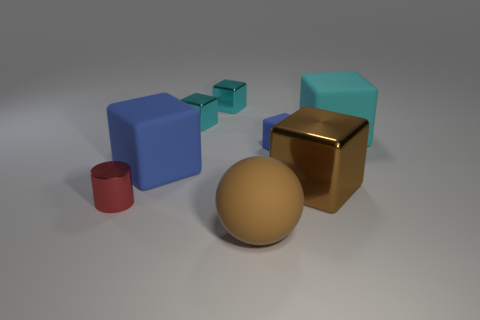Is there another object that has the same material as the small blue thing?
Provide a short and direct response. Yes. What material is the big brown object that is to the right of the tiny cube right of the brown rubber object?
Offer a very short reply. Metal. There is a shiny object in front of the big brown metal cube; how big is it?
Offer a very short reply. Small. Do the large ball and the shiny cube to the right of the brown ball have the same color?
Your answer should be very brief. Yes. Are there any other cylinders that have the same color as the tiny cylinder?
Provide a succinct answer. No. Do the small blue object and the brown object behind the small red cylinder have the same material?
Your answer should be compact. No. What number of small objects are blue rubber cylinders or brown shiny objects?
Your answer should be very brief. 0. There is a block that is the same color as the large sphere; what is its material?
Your answer should be very brief. Metal. Is the number of blocks less than the number of objects?
Offer a terse response. Yes. Is the size of the brown thing that is in front of the cylinder the same as the shiny object that is in front of the brown metal cube?
Your answer should be compact. No. 